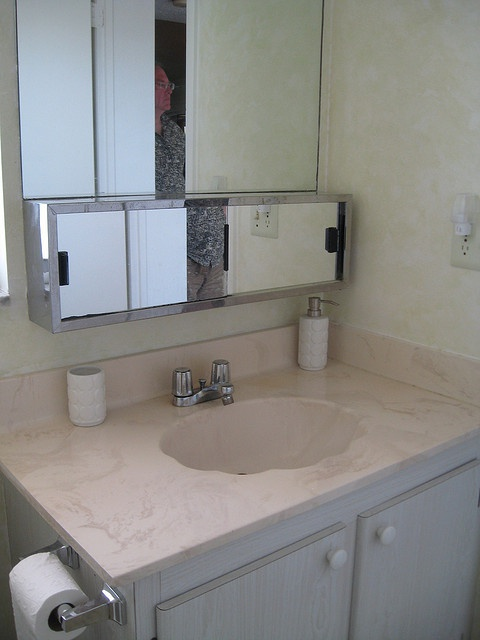Describe the objects in this image and their specific colors. I can see sink in gray and darkgray tones, people in gray and black tones, cup in gray tones, and bottle in gray tones in this image. 